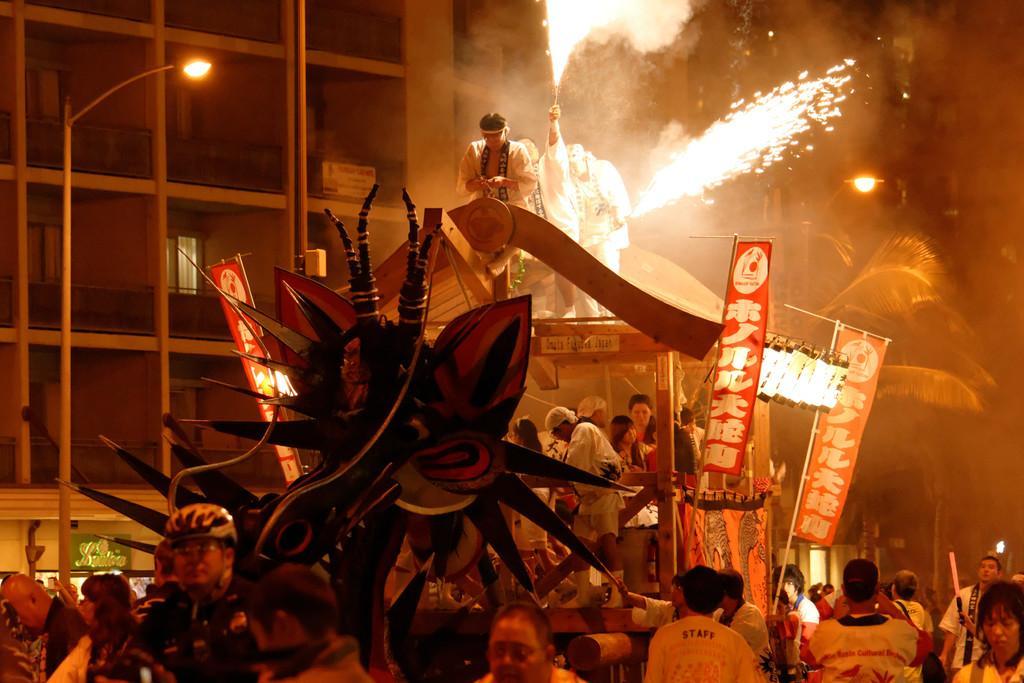How would you summarize this image in a sentence or two? In the center of the image there are people. There is a street light. In the background of the image there is a building. There are banners. 